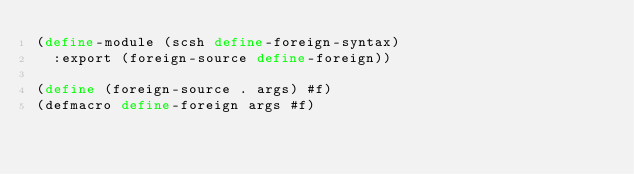Convert code to text. <code><loc_0><loc_0><loc_500><loc_500><_Scheme_>(define-module (scsh define-foreign-syntax)
  :export (foreign-source define-foreign))

(define (foreign-source . args) #f)
(defmacro define-foreign args #f)
</code> 